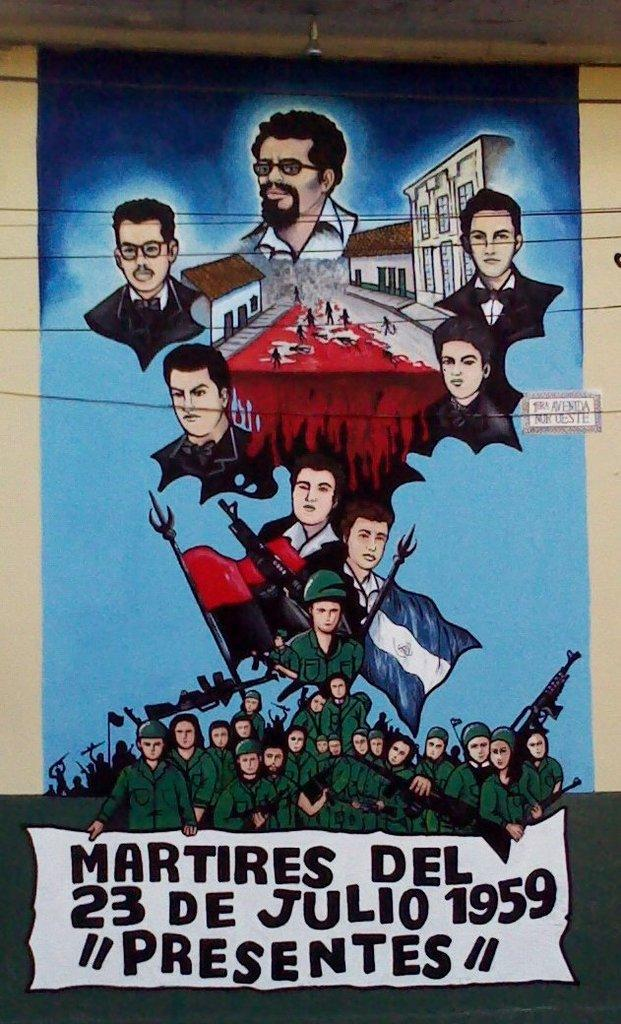Provide a one-sentence caption for the provided image. A brightly colored poster presenting the happenings of July 23 1959. 